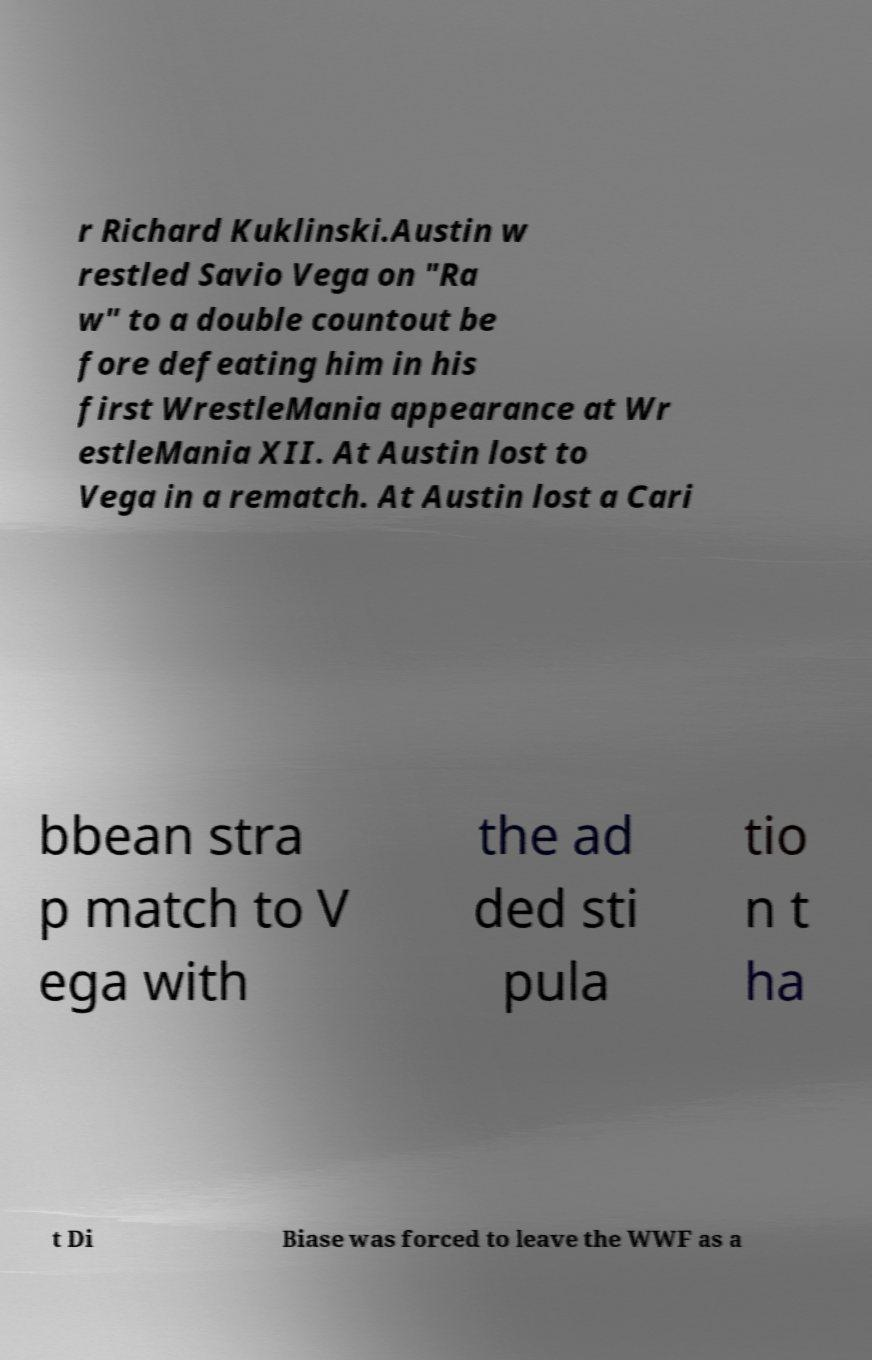I need the written content from this picture converted into text. Can you do that? r Richard Kuklinski.Austin w restled Savio Vega on "Ra w" to a double countout be fore defeating him in his first WrestleMania appearance at Wr estleMania XII. At Austin lost to Vega in a rematch. At Austin lost a Cari bbean stra p match to V ega with the ad ded sti pula tio n t ha t Di Biase was forced to leave the WWF as a 